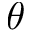Convert formula to latex. <formula><loc_0><loc_0><loc_500><loc_500>\theta</formula> 